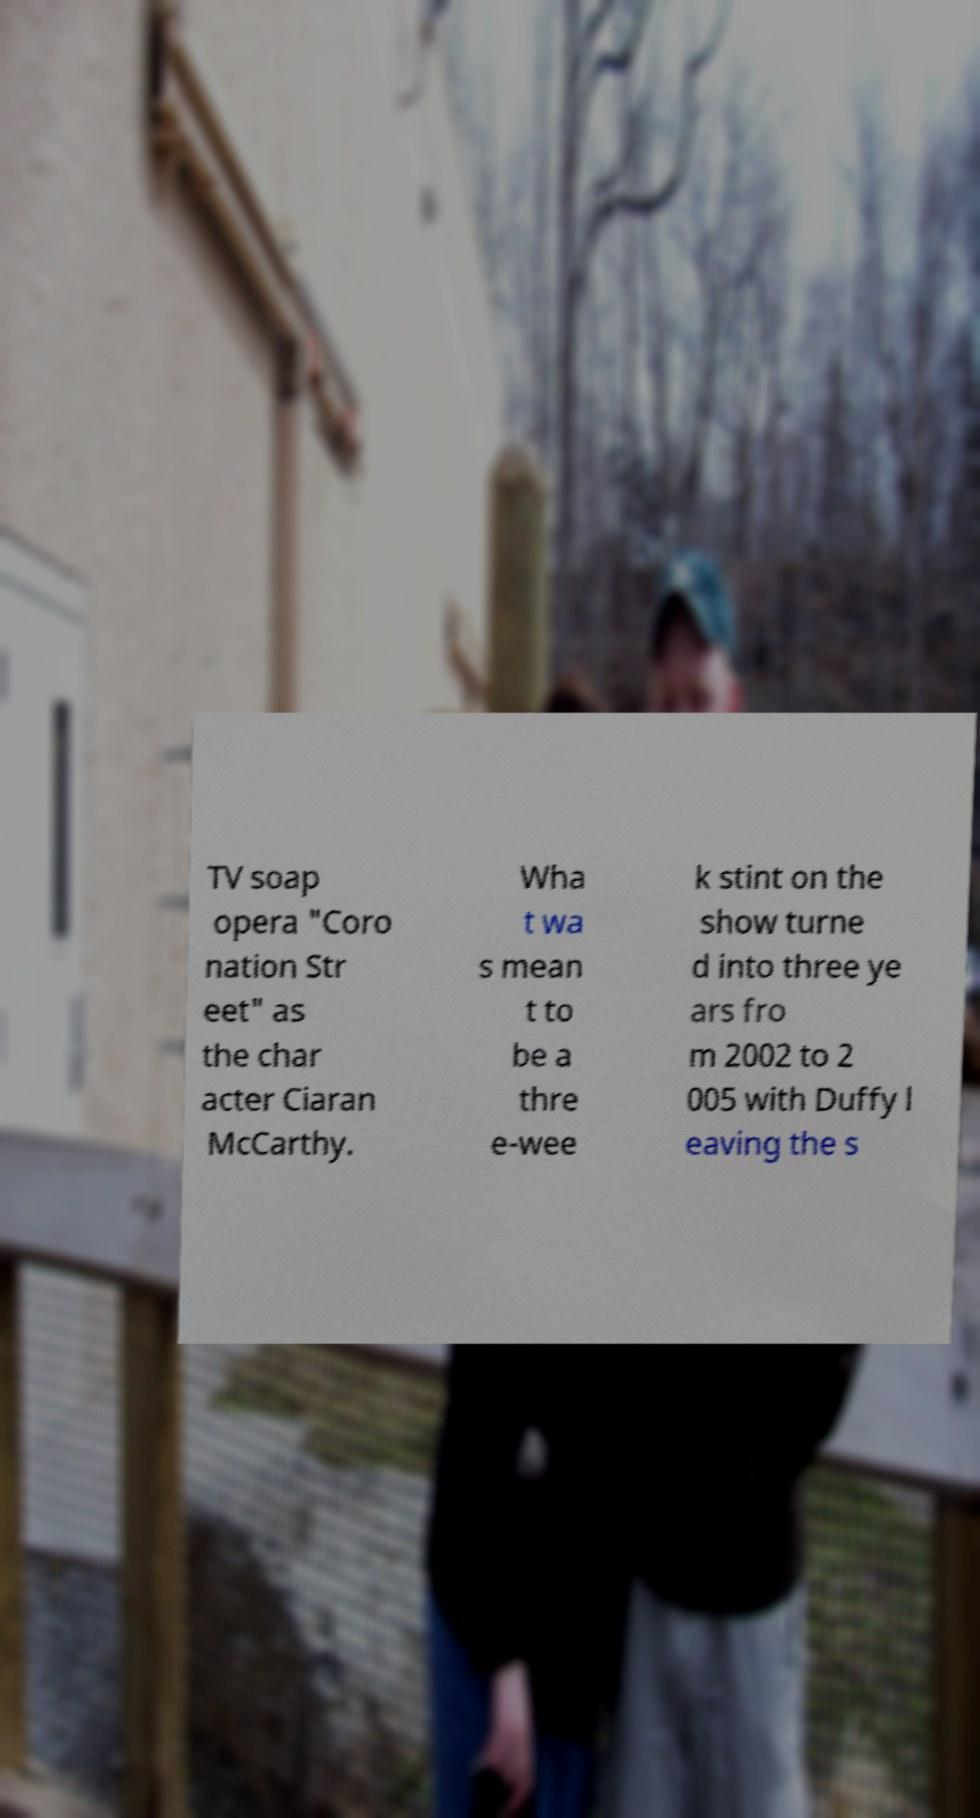I need the written content from this picture converted into text. Can you do that? TV soap opera "Coro nation Str eet" as the char acter Ciaran McCarthy. Wha t wa s mean t to be a thre e-wee k stint on the show turne d into three ye ars fro m 2002 to 2 005 with Duffy l eaving the s 